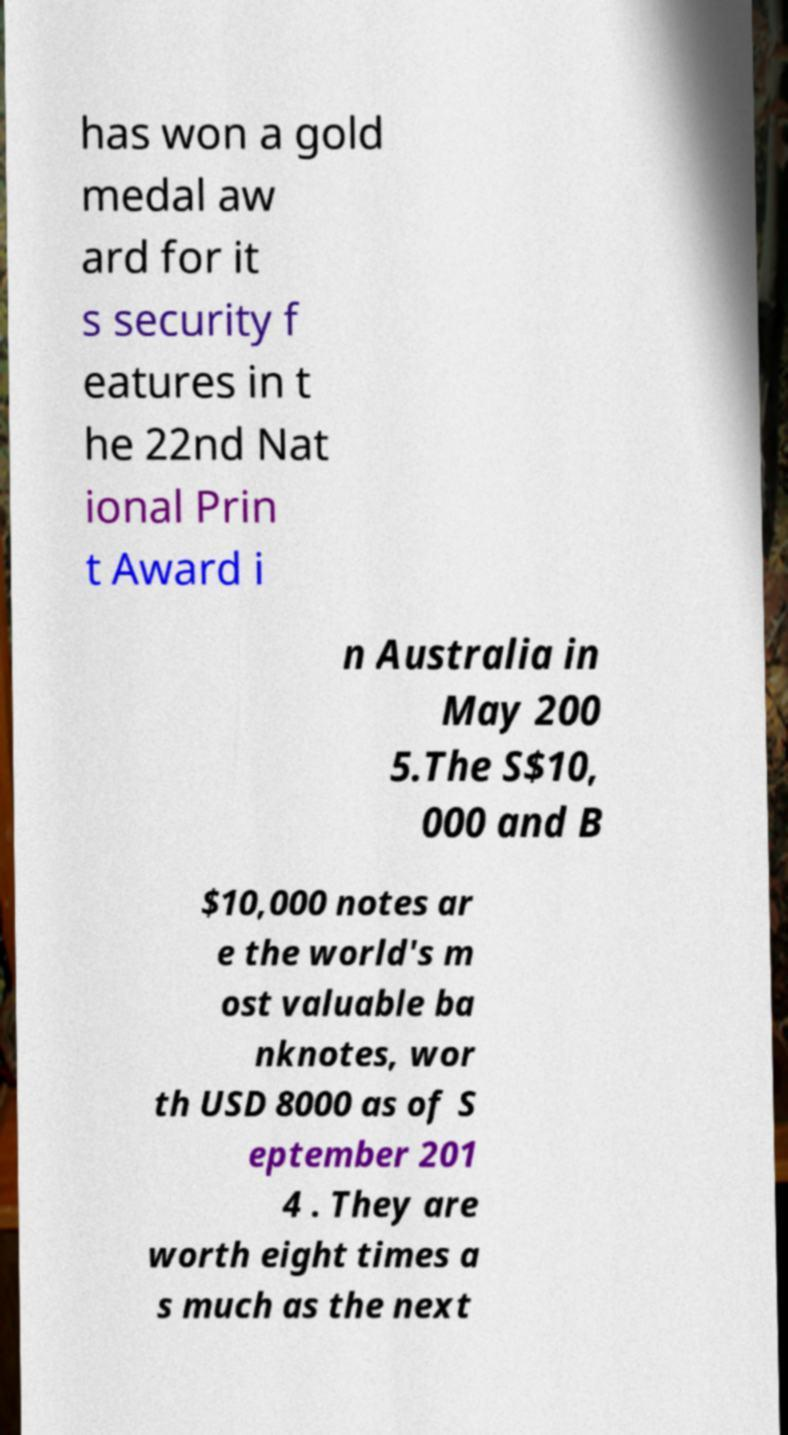Could you extract and type out the text from this image? has won a gold medal aw ard for it s security f eatures in t he 22nd Nat ional Prin t Award i n Australia in May 200 5.The S$10, 000 and B $10,000 notes ar e the world's m ost valuable ba nknotes, wor th USD 8000 as of S eptember 201 4 . They are worth eight times a s much as the next 